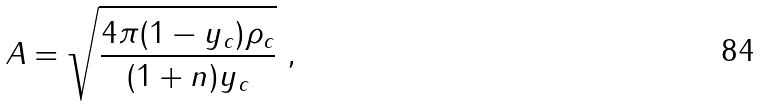<formula> <loc_0><loc_0><loc_500><loc_500>A = \sqrt { \frac { 4 \pi ( 1 - y _ { c } ) \rho _ { c } } { ( 1 + n ) y _ { c } } } \ ,</formula> 